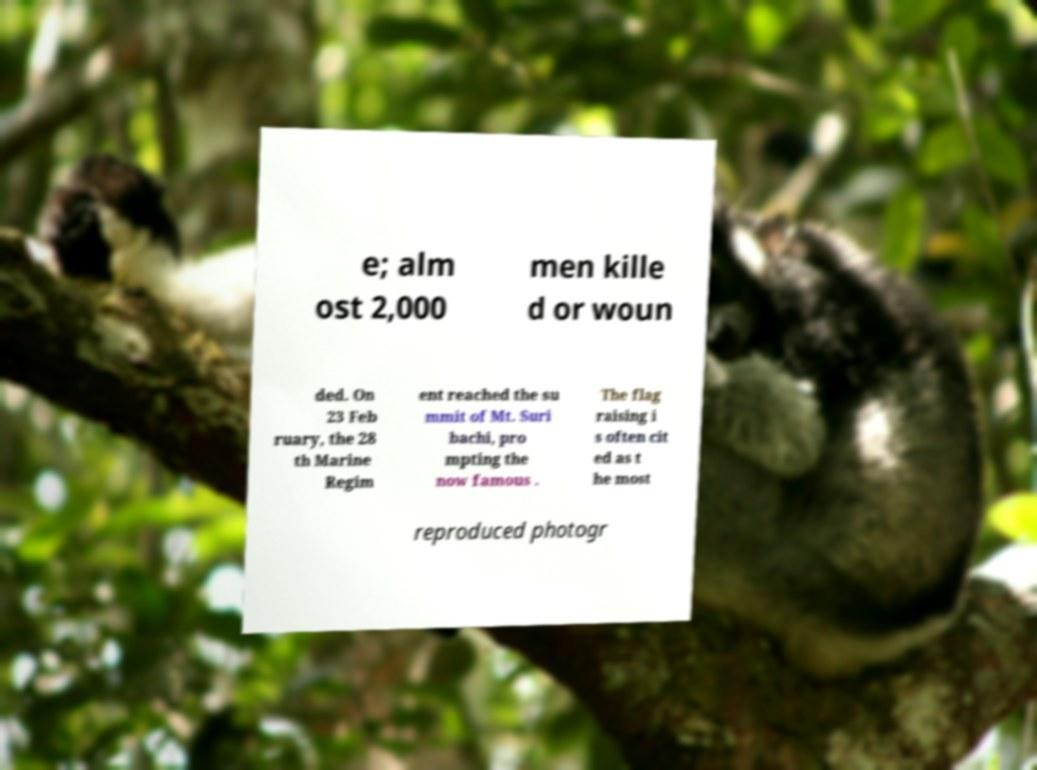What messages or text are displayed in this image? I need them in a readable, typed format. e; alm ost 2,000 men kille d or woun ded. On 23 Feb ruary, the 28 th Marine Regim ent reached the su mmit of Mt. Suri bachi, pro mpting the now famous . The flag raising i s often cit ed as t he most reproduced photogr 